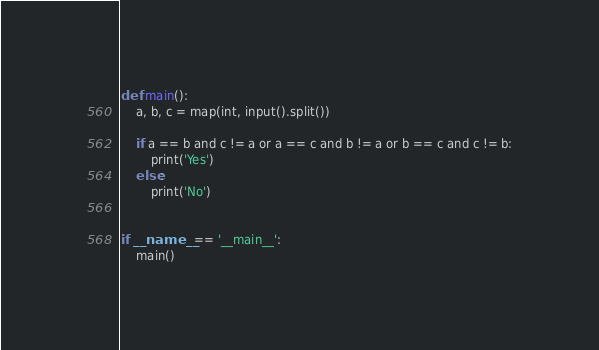<code> <loc_0><loc_0><loc_500><loc_500><_Python_>def main():
    a, b, c = map(int, input().split())

    if a == b and c != a or a == c and b != a or b == c and c != b:
        print('Yes')
    else:
        print('No')


if __name__ == '__main__':
    main()
</code> 